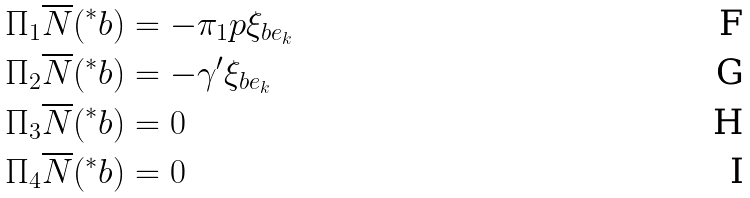Convert formula to latex. <formula><loc_0><loc_0><loc_500><loc_500>\Pi _ { 1 } \overline { N } ( ^ { \ast } b ) & = - \pi _ { 1 } p \xi _ { b e _ { k } } \\ \Pi _ { 2 } \overline { N } ( ^ { \ast } b ) & = - \gamma ^ { \prime } \xi _ { b e _ { k } } \\ \Pi _ { 3 } \overline { N } ( ^ { \ast } b ) & = 0 \\ \Pi _ { 4 } \overline { N } ( ^ { \ast } b ) & = 0</formula> 